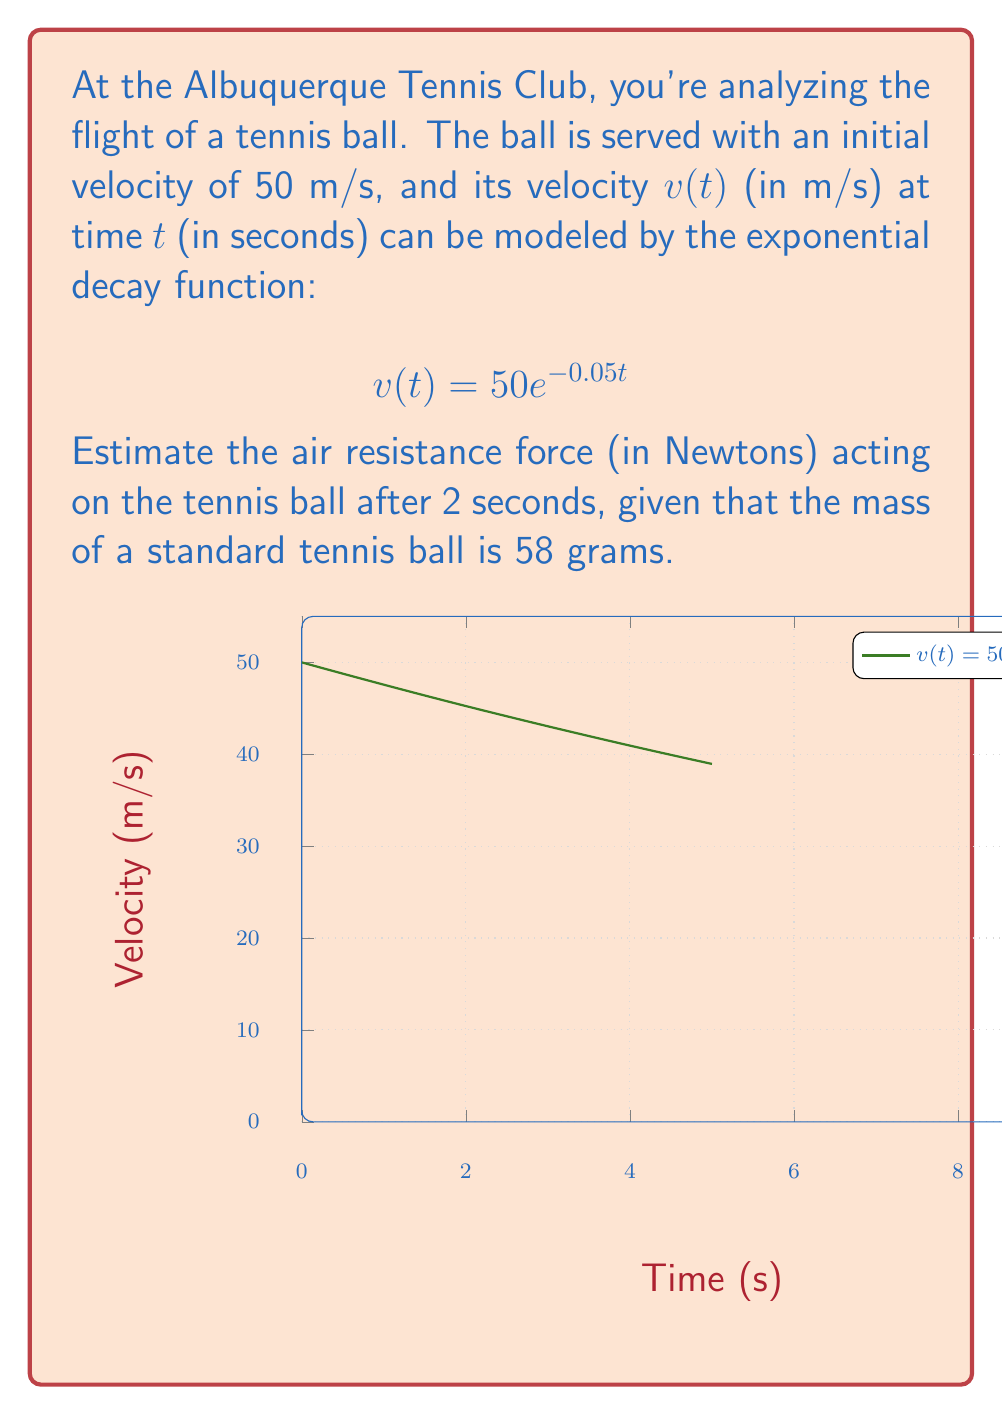Help me with this question. Let's approach this step-by-step:

1) The air resistance force $F$ is related to the rate of change of velocity. We can express this using Newton's Second Law:

   $$F = m\frac{dv}{dt}$$

   where $m$ is the mass of the tennis ball.

2) To find $\frac{dv}{dt}$, we need to differentiate $v(t)$ with respect to $t$:

   $$\frac{d}{dt}(50e^{-0.05t}) = 50 \cdot (-0.05) \cdot e^{-0.05t} = -2.5e^{-0.05t}$$

3) Now we can write our force equation:

   $$F = m \cdot (-2.5e^{-0.05t})$$

4) We're asked to find the force after 2 seconds, so let's substitute $t=2$ and $m=0.058$ kg:

   $$F = 0.058 \cdot (-2.5e^{-0.05(2)})$$

5) Let's evaluate this:

   $$F = 0.058 \cdot (-2.5 \cdot 0.9048) = -0.1312$$

6) The negative sign indicates that the force is in the opposite direction of the velocity (which is what we expect for air resistance).

Therefore, the magnitude of the air resistance force after 2 seconds is approximately 0.1312 N.
Answer: 0.1312 N 